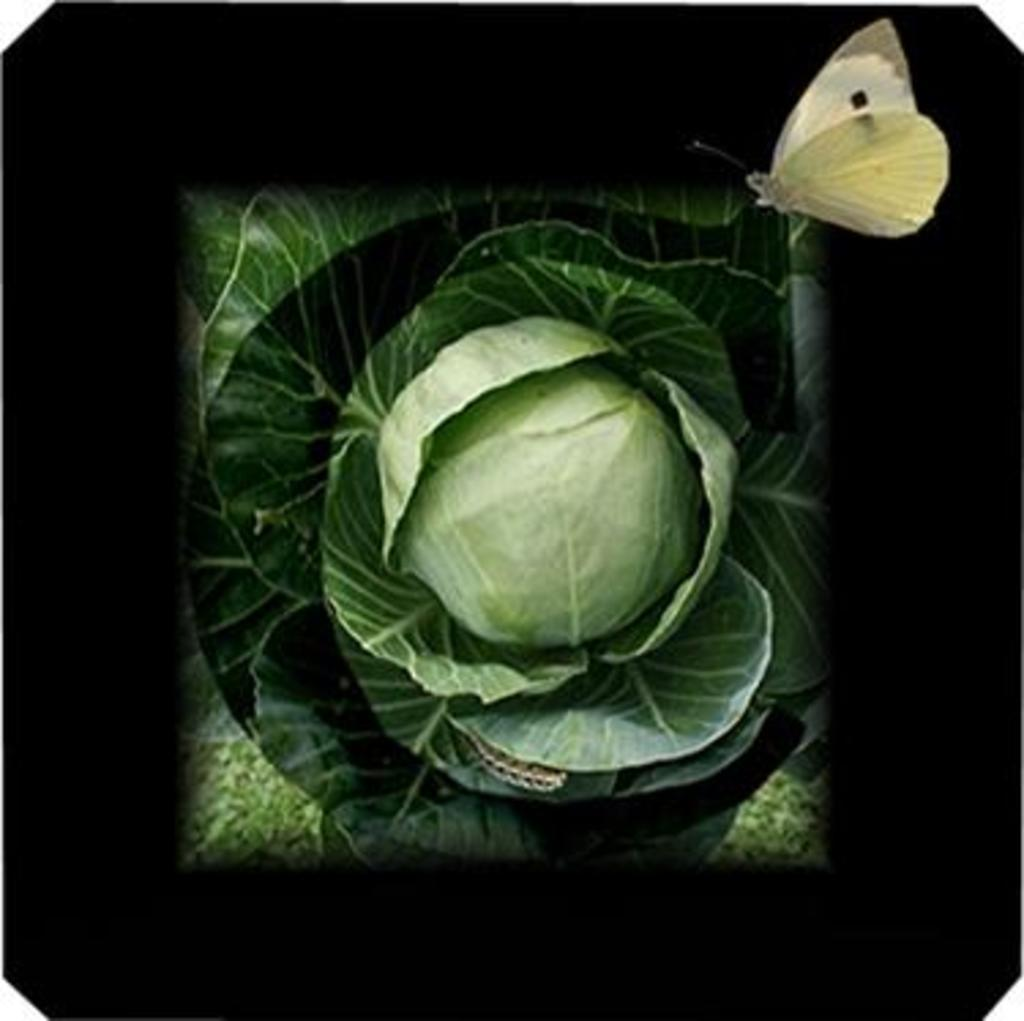What is the main subject in the center of the image? There is cabbage in the center of the image. What else can be seen in the image besides the cabbage? There are leaves in the image. How would you describe the lighting in the foreground of the image? The foreground of the image is dark. Are there any living creatures visible in the image? Yes, there is a butterfly in the image. What type of wound can be seen on the cabbage in the image? There is no wound visible on the cabbage in the image. 